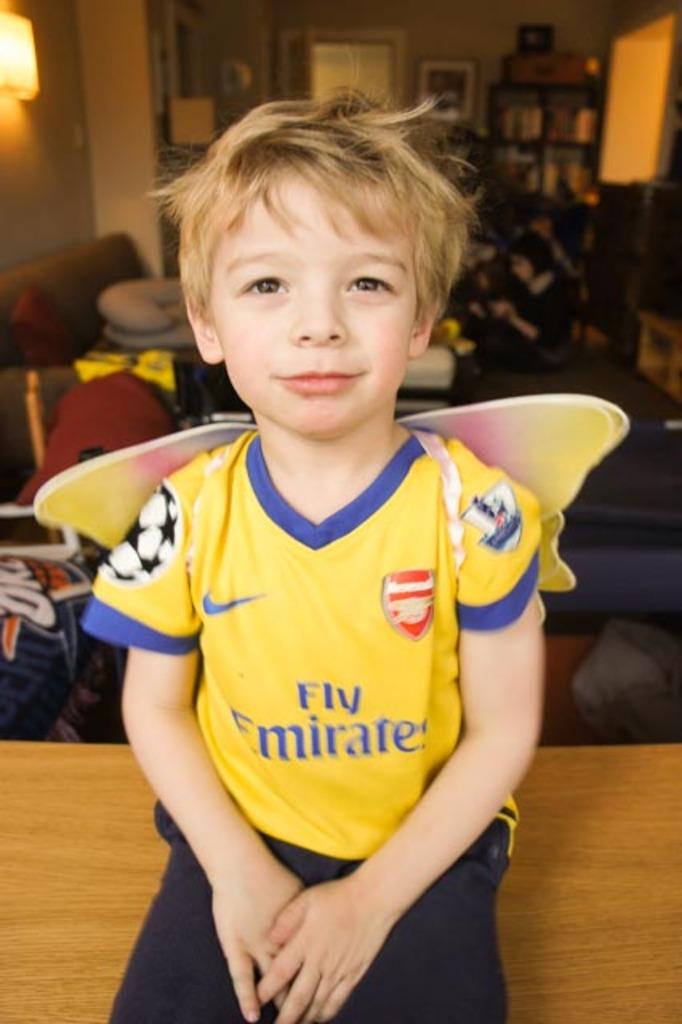What team does this child play for?
Your answer should be compact. Fly emirates. Which major sporting goods company is sponsoring this player?
Give a very brief answer. Fly emirates. 